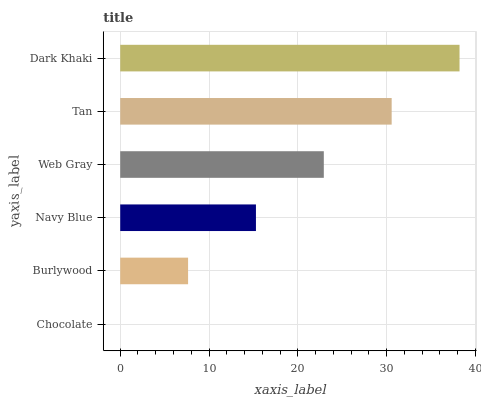Is Chocolate the minimum?
Answer yes or no. Yes. Is Dark Khaki the maximum?
Answer yes or no. Yes. Is Burlywood the minimum?
Answer yes or no. No. Is Burlywood the maximum?
Answer yes or no. No. Is Burlywood greater than Chocolate?
Answer yes or no. Yes. Is Chocolate less than Burlywood?
Answer yes or no. Yes. Is Chocolate greater than Burlywood?
Answer yes or no. No. Is Burlywood less than Chocolate?
Answer yes or no. No. Is Web Gray the high median?
Answer yes or no. Yes. Is Navy Blue the low median?
Answer yes or no. Yes. Is Navy Blue the high median?
Answer yes or no. No. Is Chocolate the low median?
Answer yes or no. No. 